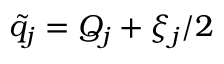Convert formula to latex. <formula><loc_0><loc_0><loc_500><loc_500>\tilde { q } _ { j } = Q _ { j } + \xi _ { j } / 2</formula> 